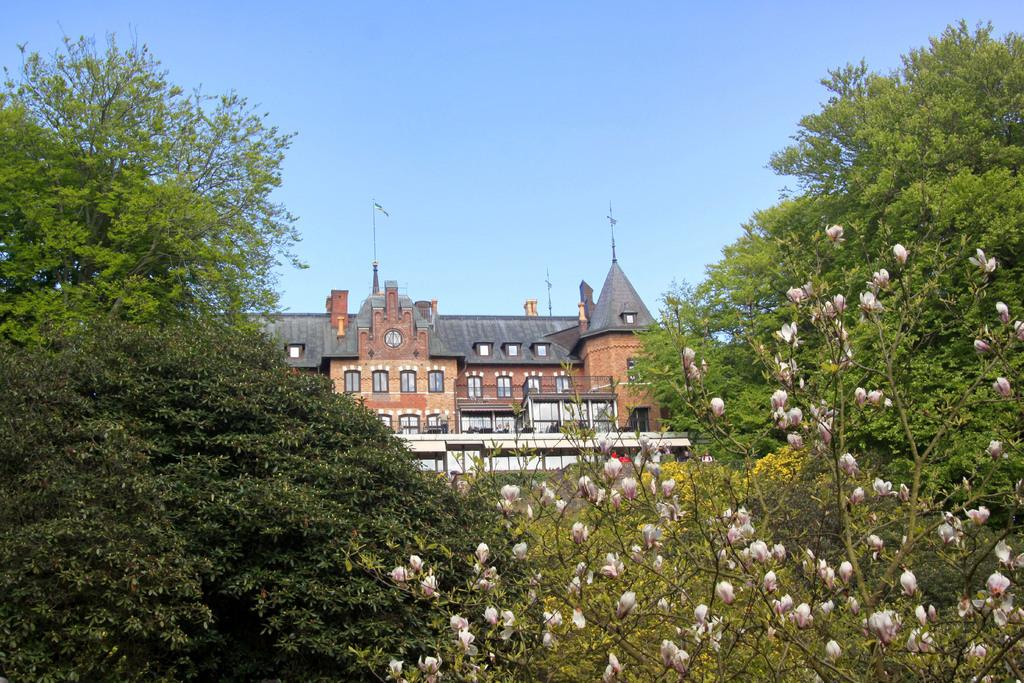What type of plants can be seen in the image? There are flowers and trees in the image. What type of structure is present in the image? There is a building with windows in the image. What can be seen in the background of the image? The sky is visible in the background of the image. Are there any fairies sitting on the branches of the trees in the image? There are no fairies present in the image; only flowers, trees, a building, and the sky are visible. 